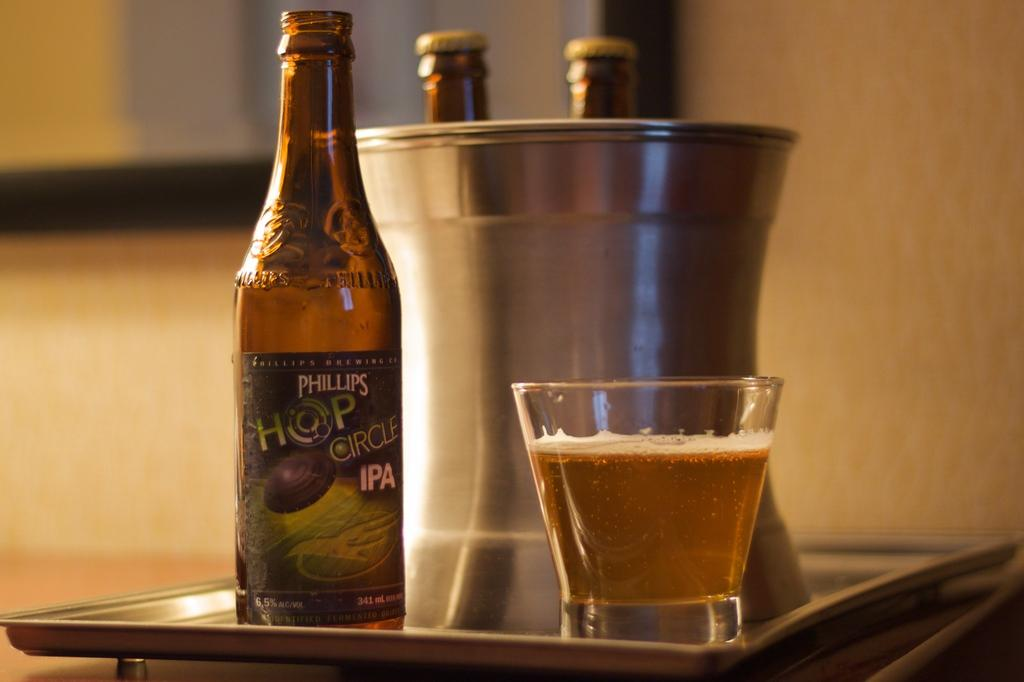<image>
Present a compact description of the photo's key features. Cup of beer next to a bottle of "Phillips Hop Circle IPA" beer. 